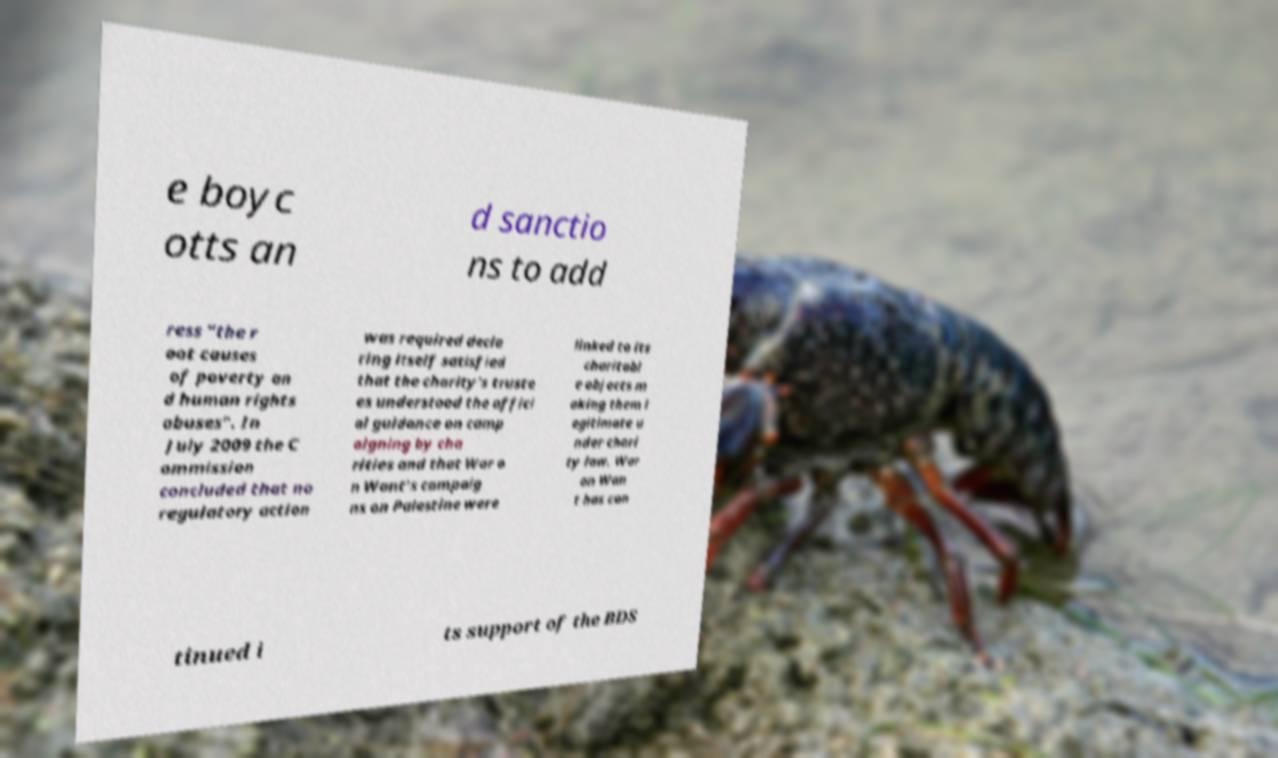Please read and relay the text visible in this image. What does it say? e boyc otts an d sanctio ns to add ress "the r oot causes of poverty an d human rights abuses". In July 2009 the C ommission concluded that no regulatory action was required decla ring itself satisfied that the charity's truste es understood the offici al guidance on camp aigning by cha rities and that War o n Want's campaig ns on Palestine were linked to its charitabl e objects m aking them l egitimate u nder chari ty law. War on Wan t has con tinued i ts support of the BDS 